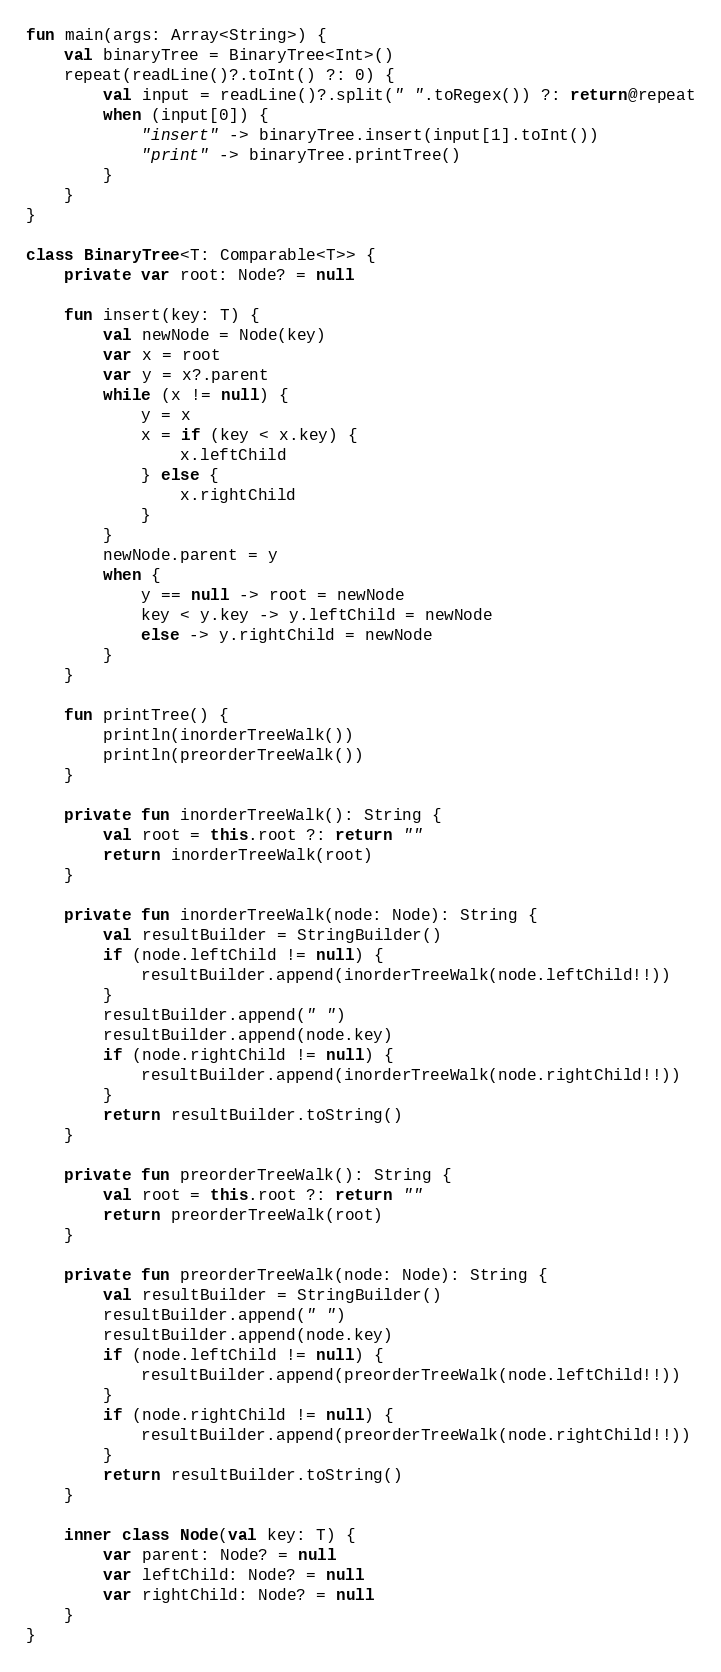<code> <loc_0><loc_0><loc_500><loc_500><_Kotlin_>fun main(args: Array<String>) {
    val binaryTree = BinaryTree<Int>()
    repeat(readLine()?.toInt() ?: 0) {
        val input = readLine()?.split(" ".toRegex()) ?: return@repeat
        when (input[0]) {
            "insert" -> binaryTree.insert(input[1].toInt())
            "print" -> binaryTree.printTree()
        }
    }
}

class BinaryTree<T: Comparable<T>> {
    private var root: Node? = null

    fun insert(key: T) {
        val newNode = Node(key)
        var x = root
        var y = x?.parent
        while (x != null) {
            y = x
            x = if (key < x.key) {
                x.leftChild
            } else {
                x.rightChild
            }
        }
        newNode.parent = y
        when {
            y == null -> root = newNode
            key < y.key -> y.leftChild = newNode
            else -> y.rightChild = newNode
        }
    }

    fun printTree() {
        println(inorderTreeWalk())
        println(preorderTreeWalk())
    }

    private fun inorderTreeWalk(): String {
        val root = this.root ?: return ""
        return inorderTreeWalk(root)
    }

    private fun inorderTreeWalk(node: Node): String {
        val resultBuilder = StringBuilder()
        if (node.leftChild != null) {
            resultBuilder.append(inorderTreeWalk(node.leftChild!!))
        }
        resultBuilder.append(" ")
        resultBuilder.append(node.key)
        if (node.rightChild != null) {
            resultBuilder.append(inorderTreeWalk(node.rightChild!!))
        }
        return resultBuilder.toString()
    }

    private fun preorderTreeWalk(): String {
        val root = this.root ?: return ""
        return preorderTreeWalk(root)
    }

    private fun preorderTreeWalk(node: Node): String {
        val resultBuilder = StringBuilder()
        resultBuilder.append(" ")
        resultBuilder.append(node.key)
        if (node.leftChild != null) {
            resultBuilder.append(preorderTreeWalk(node.leftChild!!))
        }
        if (node.rightChild != null) {
            resultBuilder.append(preorderTreeWalk(node.rightChild!!))
        }
        return resultBuilder.toString()
    }

    inner class Node(val key: T) {
        var parent: Node? = null
        var leftChild: Node? = null
        var rightChild: Node? = null
    }
}
</code> 